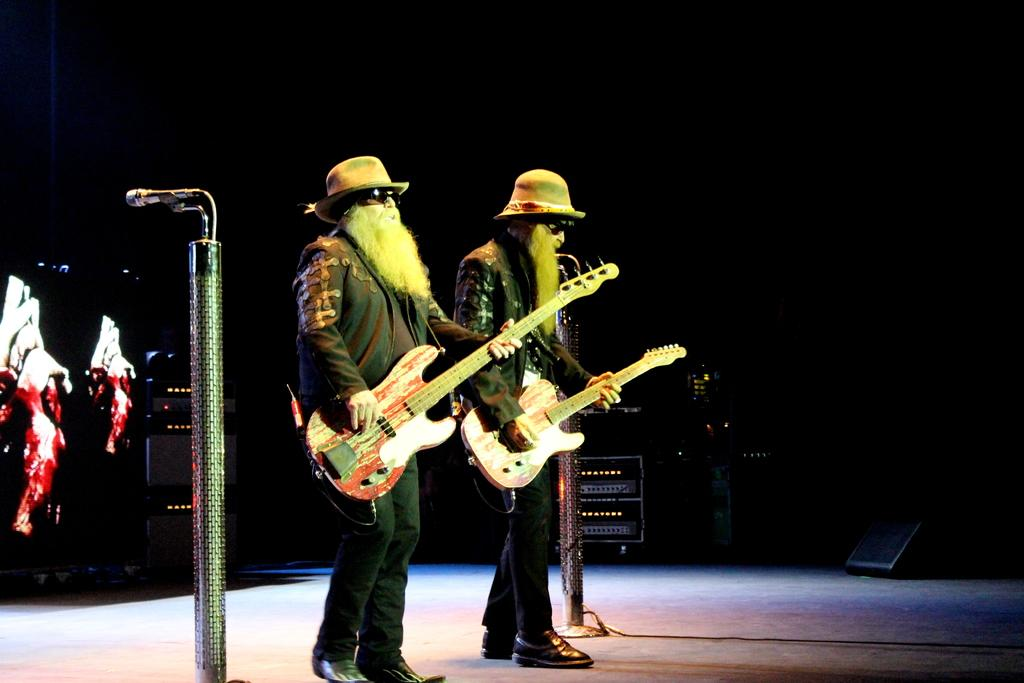How many people are in the image? There are two persons in the image. What are the persons doing in the image? The persons are playing guitar. What can be seen in the background of the image? There is a microphone and a curtain in the background. What type of frame is around the picture of the mom in the image? There is no picture of a mom or any frame present in the image. 